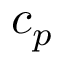<formula> <loc_0><loc_0><loc_500><loc_500>c _ { p }</formula> 